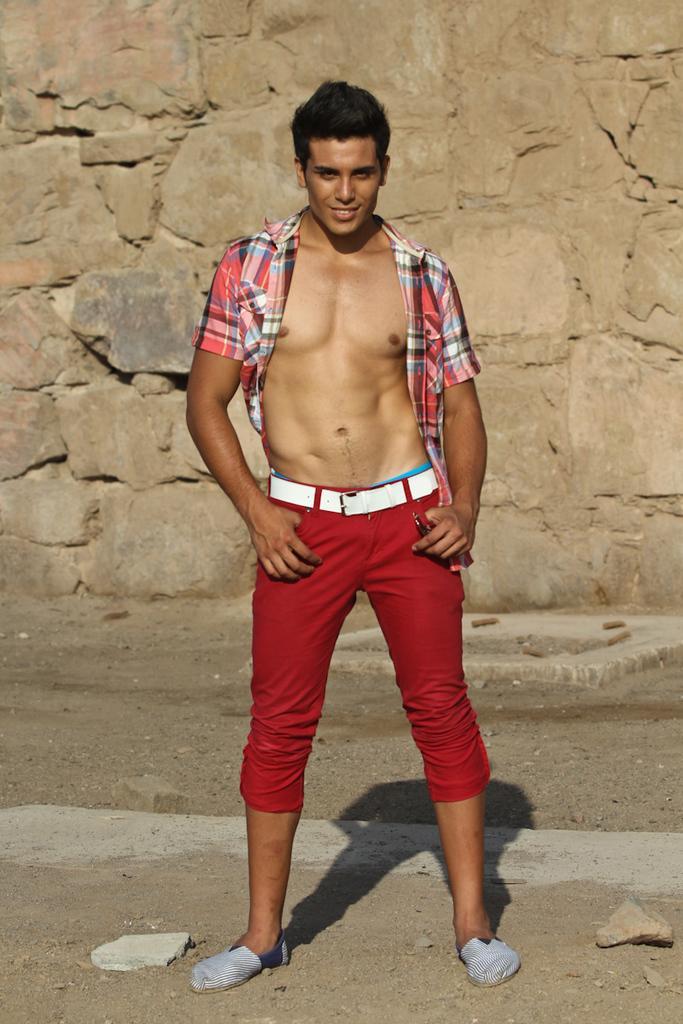Can you describe this image briefly? In the picture we can see a man standing on the path and he is in a red color trouser, a white belt and he is holding his trouser pockets with hands and he is wearing a check shirt and which the buttons are opened and showing his ABS and in the background we can see a rock wall. 